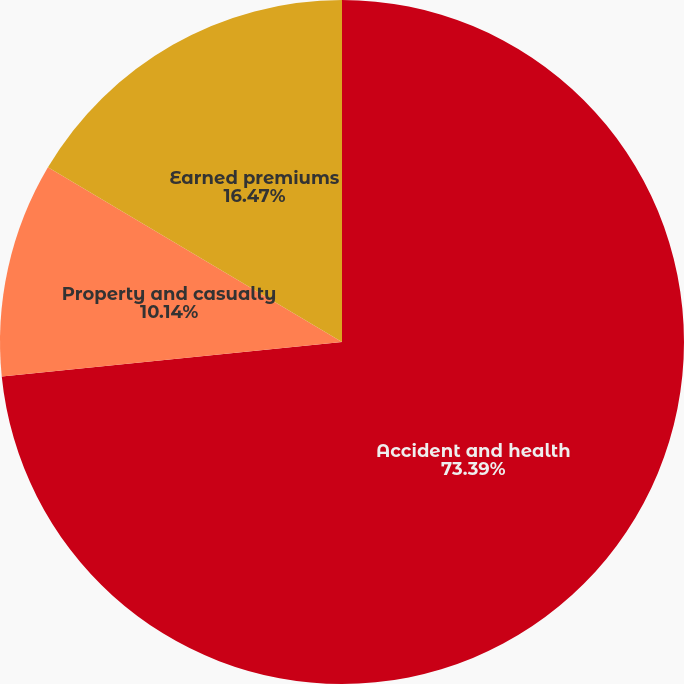Convert chart. <chart><loc_0><loc_0><loc_500><loc_500><pie_chart><fcel>Accident and health<fcel>Property and casualty<fcel>Earned premiums<nl><fcel>73.39%<fcel>10.14%<fcel>16.47%<nl></chart> 